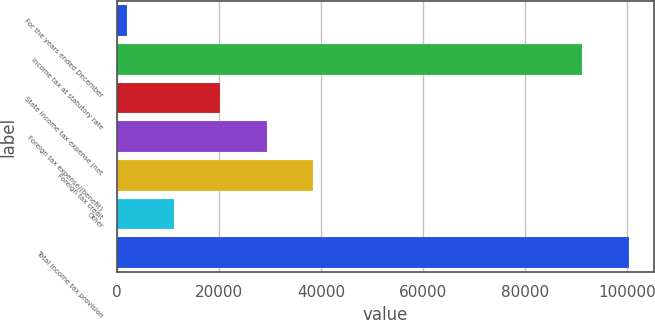Convert chart to OTSL. <chart><loc_0><loc_0><loc_500><loc_500><bar_chart><fcel>For the years ended December<fcel>Income tax at statutory rate<fcel>State income tax expense (net<fcel>Foreign tax expense/(benefit)<fcel>Foreign tax credit<fcel>Other<fcel>Total income tax provision<nl><fcel>2016<fcel>91222<fcel>20266.2<fcel>29391.3<fcel>38516.4<fcel>11141.1<fcel>100347<nl></chart> 